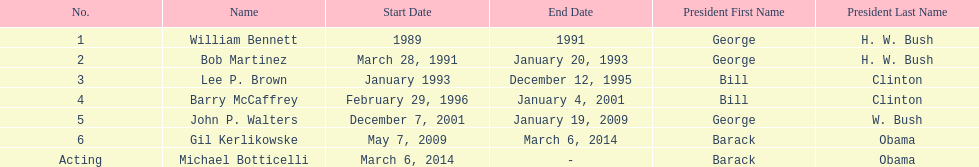What were the total number of years bob martinez served in office? 2. 